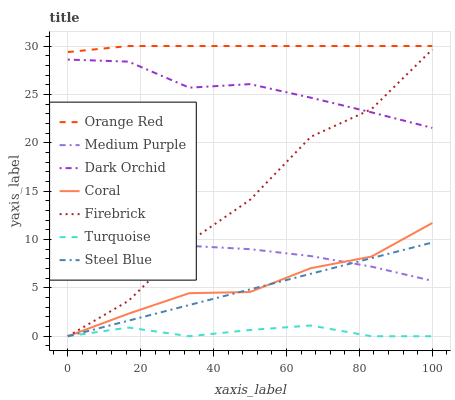Does Turquoise have the minimum area under the curve?
Answer yes or no. Yes. Does Orange Red have the maximum area under the curve?
Answer yes or no. Yes. Does Firebrick have the minimum area under the curve?
Answer yes or no. No. Does Firebrick have the maximum area under the curve?
Answer yes or no. No. Is Steel Blue the smoothest?
Answer yes or no. Yes. Is Firebrick the roughest?
Answer yes or no. Yes. Is Firebrick the smoothest?
Answer yes or no. No. Is Steel Blue the roughest?
Answer yes or no. No. Does Turquoise have the lowest value?
Answer yes or no. Yes. Does Dark Orchid have the lowest value?
Answer yes or no. No. Does Orange Red have the highest value?
Answer yes or no. Yes. Does Firebrick have the highest value?
Answer yes or no. No. Is Medium Purple less than Orange Red?
Answer yes or no. Yes. Is Orange Red greater than Turquoise?
Answer yes or no. Yes. Does Dark Orchid intersect Firebrick?
Answer yes or no. Yes. Is Dark Orchid less than Firebrick?
Answer yes or no. No. Is Dark Orchid greater than Firebrick?
Answer yes or no. No. Does Medium Purple intersect Orange Red?
Answer yes or no. No. 